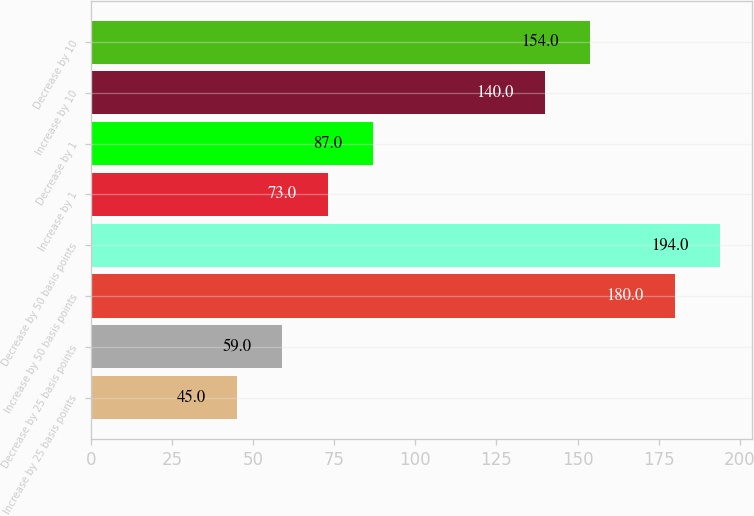<chart> <loc_0><loc_0><loc_500><loc_500><bar_chart><fcel>Increase by 25 basis points<fcel>Decrease by 25 basis points<fcel>Increase by 50 basis points<fcel>Decrease by 50 basis points<fcel>Increase by 1<fcel>Decrease by 1<fcel>Increase by 10<fcel>Decrease by 10<nl><fcel>45<fcel>59<fcel>180<fcel>194<fcel>73<fcel>87<fcel>140<fcel>154<nl></chart> 